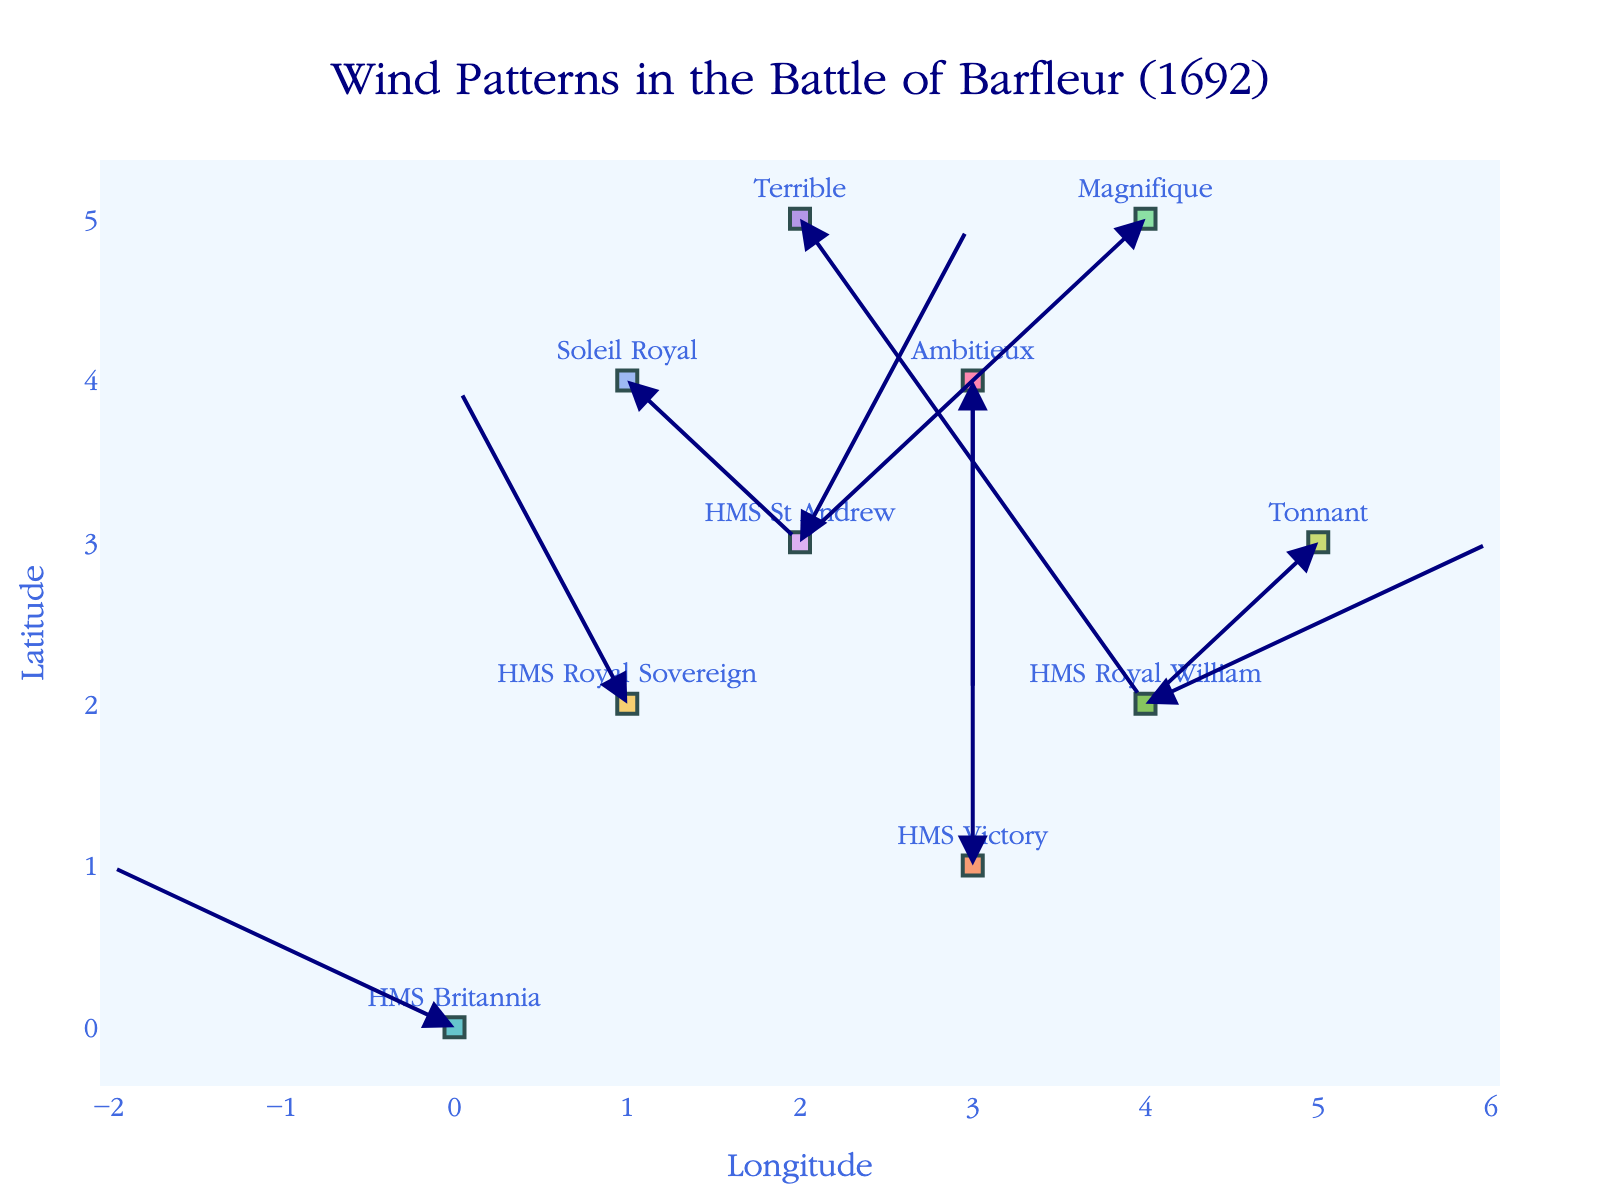What is the title of the figure? The title of the figure is located at the top center of the plot. It reads "Wind Patterns in the Battle of Barfleur (1692)".
Answer: Wind Patterns in the Battle of Barfleur (1692) How many ships are represented in the plot? To find the number of ships, count the unique names in the figure. Based on the labels, there are 10 ships.
Answer: 10 Which ship experiences the strongest wind in the y-direction? Look at the length of the arrows' vertical component (v). "Terrible" has the largest negative y component (-3).
Answer: Terrible What is the net wind displacement (u+v) for "HMS Victory"? For “HMS Victory,” sum the u and v components of the wind. u=0 and v=3, so the sum is 0+3.
Answer: 3 How many ships have a positive wind displacement in the x-direction? Count the ships where the arrow points to the right (u > 0). These ships are "HMS St Andrew," "HMS Royal William," "Soleil Royal," and "Terrible".
Answer: 4 Which ship experiences wind towards the northwest direction? Winds towards the northwest have both negative x and y components. "Magnifique" (u=-2, v=-2) and "Tonnant" (u=-1, v=-1) meet this criterion.
Answer: Magnifique, Tonnant Between "HMS Britannia" and "HMS Royal Sovereign", which ship is more affected by the wind (based on the length of the arrow)? Calculate the arrow length using the square root of the sum of squares of u and v. "HMS Britannia" (sqrt((-2)^2 + 1^2) = sqrt(5)), "HMS Royal Sovereign" (sqrt((-1)^2 + 2^2) = sqrt(5)). They are equally affected.
Answer: Equally affected Which ship is closest to the position (4, 4)? Calculate the Euclidean distance between each ship’s position and (4, 4). "Magnifique" (distance = sqrt((4-4)^2 + (5-4)^2) = 1) is the closest.
Answer: Magnifique Which direction is the wind blowing for "Soleil Royal"? Look at the arrow for "Soleil Royal". The arrow indicates a direction to the right and slightly upwards (u=1, v=-1). This means the wind is blowing towards the northeast.
Answer: Northeast What is the average wind displacement (u and v combined) in the x-direction for all ships? Sum the u components for all ships and divide by the number of ships: (-2) + (-1) + 0 + 1 + 2 + 1 + 0 + (-1) + (-2) + 2 = 0. Divide by 10: 0/10.
Answer: 0 